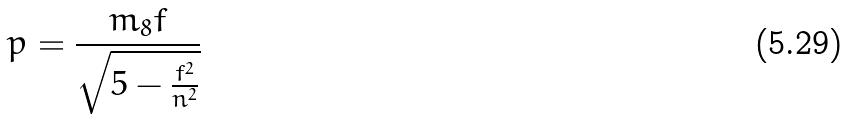<formula> <loc_0><loc_0><loc_500><loc_500>p = \frac { m _ { 8 } f } { \sqrt { 5 - \frac { f ^ { 2 } } { n ^ { 2 } } } }</formula> 